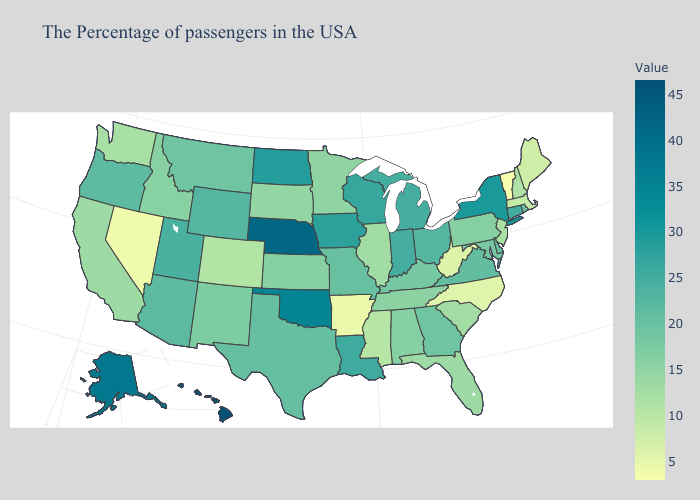Is the legend a continuous bar?
Write a very short answer. Yes. Does Alabama have the lowest value in the South?
Be succinct. No. Which states hav the highest value in the MidWest?
Quick response, please. Nebraska. 